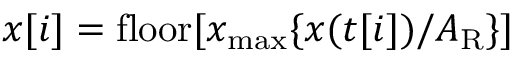<formula> <loc_0><loc_0><loc_500><loc_500>x [ i ] = f l o o r [ x _ { \max } \{ x ( t [ i ] ) / A _ { R } \} ]</formula> 